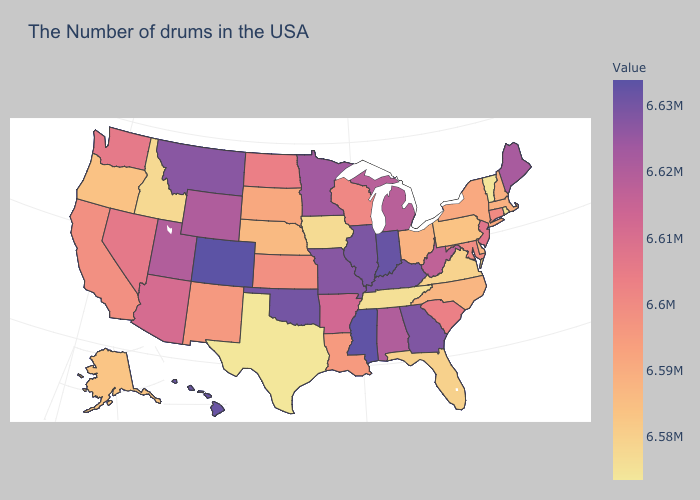Among the states that border Georgia , does Tennessee have the lowest value?
Concise answer only. Yes. Which states have the lowest value in the USA?
Write a very short answer. Texas. Which states hav the highest value in the South?
Give a very brief answer. Mississippi. Among the states that border Colorado , which have the lowest value?
Answer briefly. Nebraska. Which states have the lowest value in the USA?
Keep it brief. Texas. Among the states that border Indiana , which have the highest value?
Quick response, please. Kentucky. Among the states that border Missouri , does Kentucky have the highest value?
Be succinct. No. Does South Dakota have a higher value than Alaska?
Give a very brief answer. Yes. Among the states that border Oklahoma , which have the lowest value?
Concise answer only. Texas. 